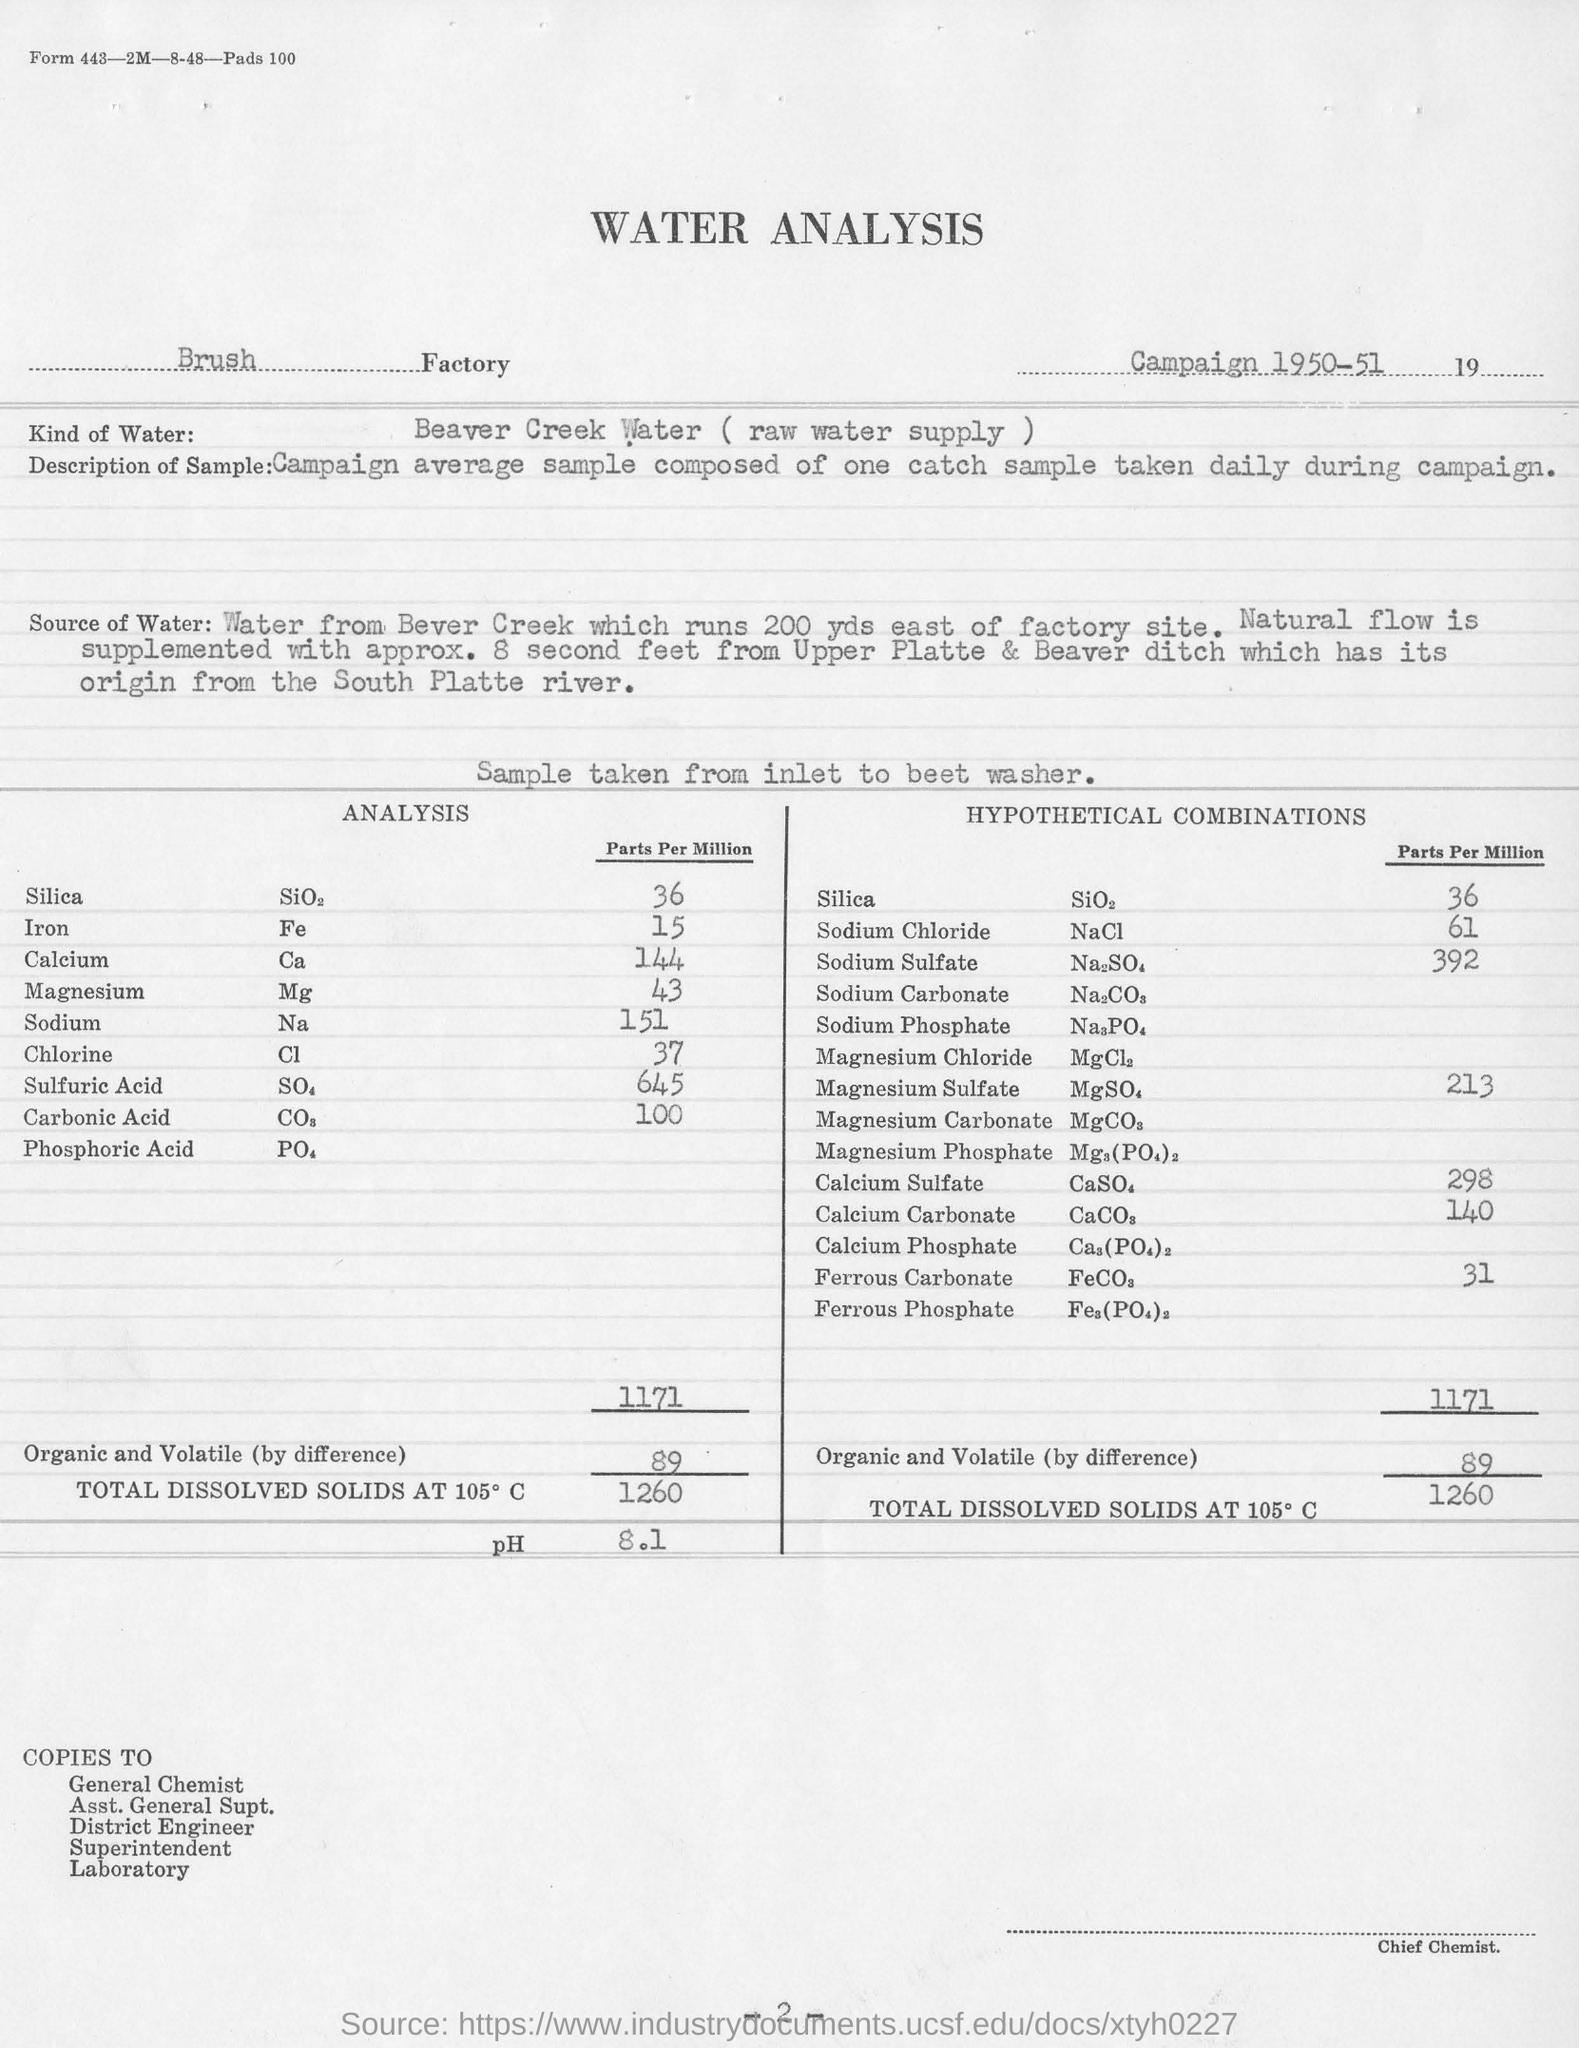What  kind of water was used in the analysis?
Provide a short and direct response. Beaver Creek Water. In which factory was the water analysis done?
Make the answer very short. Brush Factory. What is the pH mentioned?
Offer a very short reply. 8.1. Where was the sample of water taken from?
Provide a short and direct response. Beaver Creek. 